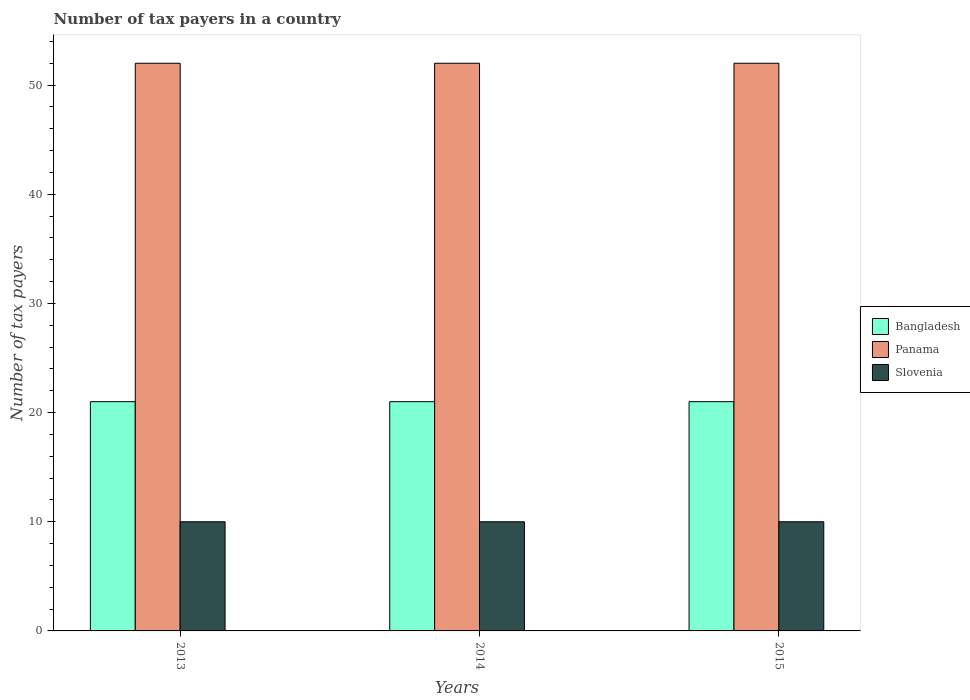How many bars are there on the 2nd tick from the left?
Give a very brief answer. 3. How many bars are there on the 3rd tick from the right?
Ensure brevity in your answer.  3. What is the label of the 3rd group of bars from the left?
Make the answer very short. 2015. Across all years, what is the maximum number of tax payers in in Panama?
Provide a short and direct response. 52. Across all years, what is the minimum number of tax payers in in Slovenia?
Give a very brief answer. 10. What is the total number of tax payers in in Slovenia in the graph?
Your response must be concise. 30. What is the difference between the number of tax payers in in Panama in 2013 and that in 2014?
Offer a very short reply. 0. What is the difference between the number of tax payers in in Bangladesh in 2015 and the number of tax payers in in Slovenia in 2013?
Provide a succinct answer. 11. In how many years, is the number of tax payers in in Bangladesh greater than 22?
Your answer should be very brief. 0. What is the ratio of the number of tax payers in in Slovenia in 2013 to that in 2014?
Offer a terse response. 1. Is the difference between the number of tax payers in in Panama in 2013 and 2015 greater than the difference between the number of tax payers in in Bangladesh in 2013 and 2015?
Your response must be concise. No. What is the difference between the highest and the second highest number of tax payers in in Panama?
Your answer should be very brief. 0. In how many years, is the number of tax payers in in Bangladesh greater than the average number of tax payers in in Bangladesh taken over all years?
Make the answer very short. 0. What does the 2nd bar from the left in 2014 represents?
Offer a terse response. Panama. What does the 2nd bar from the right in 2013 represents?
Your response must be concise. Panama. Is it the case that in every year, the sum of the number of tax payers in in Slovenia and number of tax payers in in Panama is greater than the number of tax payers in in Bangladesh?
Your answer should be compact. Yes. How many bars are there?
Your answer should be very brief. 9. Are the values on the major ticks of Y-axis written in scientific E-notation?
Provide a succinct answer. No. How many legend labels are there?
Provide a succinct answer. 3. How are the legend labels stacked?
Provide a succinct answer. Vertical. What is the title of the graph?
Your answer should be compact. Number of tax payers in a country. Does "Peru" appear as one of the legend labels in the graph?
Your answer should be very brief. No. What is the label or title of the X-axis?
Provide a succinct answer. Years. What is the label or title of the Y-axis?
Ensure brevity in your answer.  Number of tax payers. What is the Number of tax payers of Bangladesh in 2013?
Your answer should be compact. 21. What is the Number of tax payers in Panama in 2013?
Ensure brevity in your answer.  52. What is the Number of tax payers of Panama in 2014?
Ensure brevity in your answer.  52. What is the Number of tax payers of Slovenia in 2015?
Your response must be concise. 10. Across all years, what is the minimum Number of tax payers in Bangladesh?
Offer a terse response. 21. Across all years, what is the minimum Number of tax payers of Slovenia?
Give a very brief answer. 10. What is the total Number of tax payers in Bangladesh in the graph?
Your response must be concise. 63. What is the total Number of tax payers of Panama in the graph?
Give a very brief answer. 156. What is the difference between the Number of tax payers in Bangladesh in 2013 and that in 2014?
Your response must be concise. 0. What is the difference between the Number of tax payers of Panama in 2013 and that in 2014?
Offer a terse response. 0. What is the difference between the Number of tax payers in Bangladesh in 2013 and that in 2015?
Offer a terse response. 0. What is the difference between the Number of tax payers in Slovenia in 2013 and that in 2015?
Ensure brevity in your answer.  0. What is the difference between the Number of tax payers in Bangladesh in 2014 and that in 2015?
Provide a succinct answer. 0. What is the difference between the Number of tax payers of Bangladesh in 2013 and the Number of tax payers of Panama in 2014?
Make the answer very short. -31. What is the difference between the Number of tax payers in Bangladesh in 2013 and the Number of tax payers in Panama in 2015?
Your answer should be compact. -31. What is the difference between the Number of tax payers of Panama in 2013 and the Number of tax payers of Slovenia in 2015?
Keep it short and to the point. 42. What is the difference between the Number of tax payers in Bangladesh in 2014 and the Number of tax payers in Panama in 2015?
Provide a succinct answer. -31. What is the difference between the Number of tax payers of Bangladesh in 2014 and the Number of tax payers of Slovenia in 2015?
Make the answer very short. 11. What is the average Number of tax payers of Bangladesh per year?
Your response must be concise. 21. What is the average Number of tax payers in Panama per year?
Keep it short and to the point. 52. What is the average Number of tax payers of Slovenia per year?
Ensure brevity in your answer.  10. In the year 2013, what is the difference between the Number of tax payers of Bangladesh and Number of tax payers of Panama?
Offer a terse response. -31. In the year 2013, what is the difference between the Number of tax payers in Panama and Number of tax payers in Slovenia?
Your response must be concise. 42. In the year 2014, what is the difference between the Number of tax payers of Bangladesh and Number of tax payers of Panama?
Give a very brief answer. -31. In the year 2014, what is the difference between the Number of tax payers of Bangladesh and Number of tax payers of Slovenia?
Your answer should be very brief. 11. In the year 2014, what is the difference between the Number of tax payers of Panama and Number of tax payers of Slovenia?
Keep it short and to the point. 42. In the year 2015, what is the difference between the Number of tax payers in Bangladesh and Number of tax payers in Panama?
Make the answer very short. -31. In the year 2015, what is the difference between the Number of tax payers in Bangladesh and Number of tax payers in Slovenia?
Give a very brief answer. 11. In the year 2015, what is the difference between the Number of tax payers of Panama and Number of tax payers of Slovenia?
Your response must be concise. 42. What is the ratio of the Number of tax payers in Bangladesh in 2013 to that in 2014?
Provide a short and direct response. 1. What is the ratio of the Number of tax payers in Bangladesh in 2013 to that in 2015?
Ensure brevity in your answer.  1. What is the ratio of the Number of tax payers of Bangladesh in 2014 to that in 2015?
Provide a succinct answer. 1. What is the ratio of the Number of tax payers in Panama in 2014 to that in 2015?
Offer a terse response. 1. What is the ratio of the Number of tax payers of Slovenia in 2014 to that in 2015?
Offer a terse response. 1. What is the difference between the highest and the second highest Number of tax payers in Bangladesh?
Your response must be concise. 0. What is the difference between the highest and the second highest Number of tax payers of Panama?
Offer a terse response. 0. What is the difference between the highest and the lowest Number of tax payers in Panama?
Provide a short and direct response. 0. 